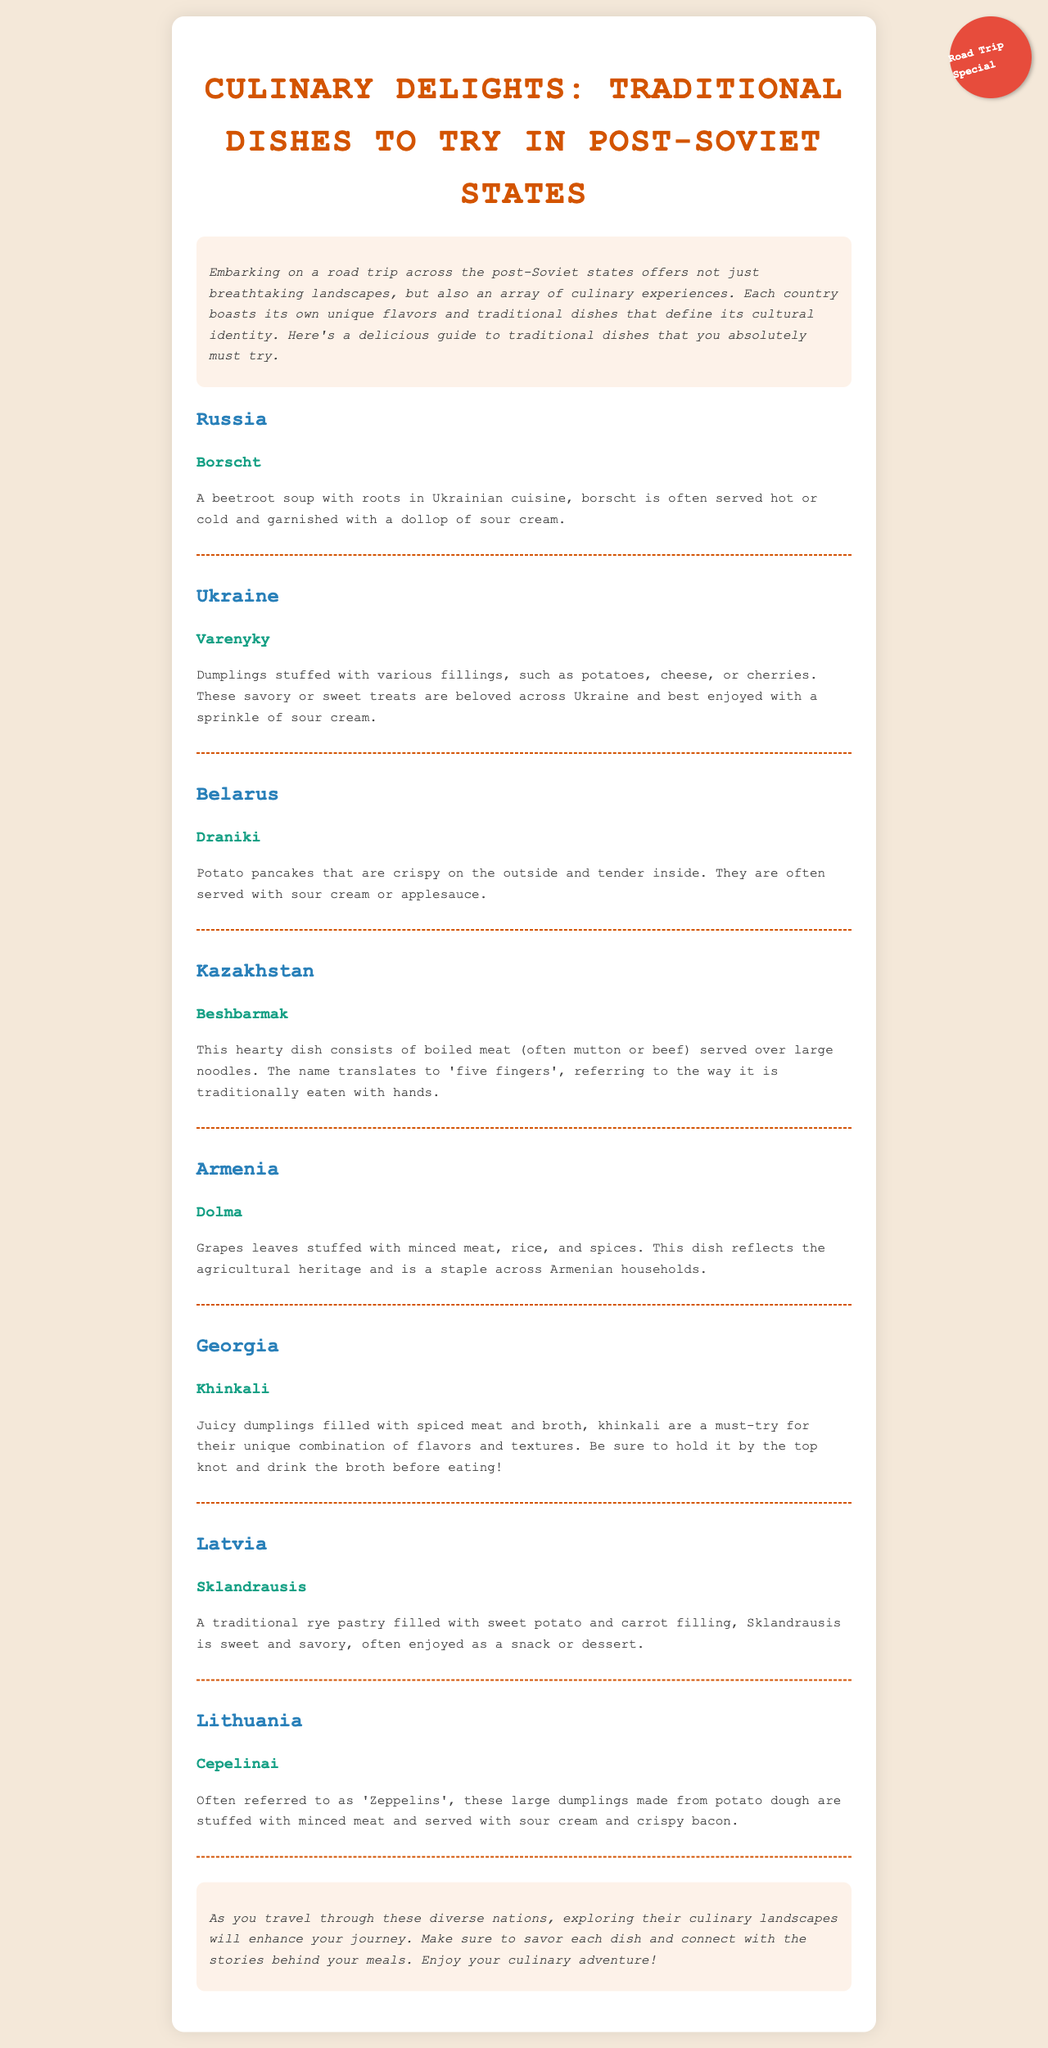what is the title of the document? The title of the document is prominently displayed at the top, indicating the document's primary focus.
Answer: Culinary Delights: Traditional Dishes to Try in Post-Soviet States which country is associated with Borscht? Borscht is specifically mentioned in the section about Russia, indicating its culinary significance there.
Answer: Russia what traditional dish is famous in Ukraine? The document lists a specific traditional dish that is beloved in Ukraine.
Answer: Varenyky how is Beshbarmak traditionally eaten? The explanation for Beshbarmak includes details about how it is consumed, highlighting a cultural aspect of the dish.
Answer: with hands what is the filling of Sklandrausis? The document provides specific information about what is used as filling in the traditional pastry Sklandrausis.
Answer: sweet potato and carrot which dish is referred to as 'Zeppelins'? The document uses a colloquial name for a traditional dish served in Lithuania, clarifying its popular nickname.
Answer: Cepelinai what type of cuisine is Dolma? The section on Dolma indicates its culinary heritage and the cultural significance associated with it.
Answer: Armenian how many traditional dishes are listed in the document? By counting occurrences, one can ascertain the number of distinct traditional dishes featured in the document.
Answer: 8 